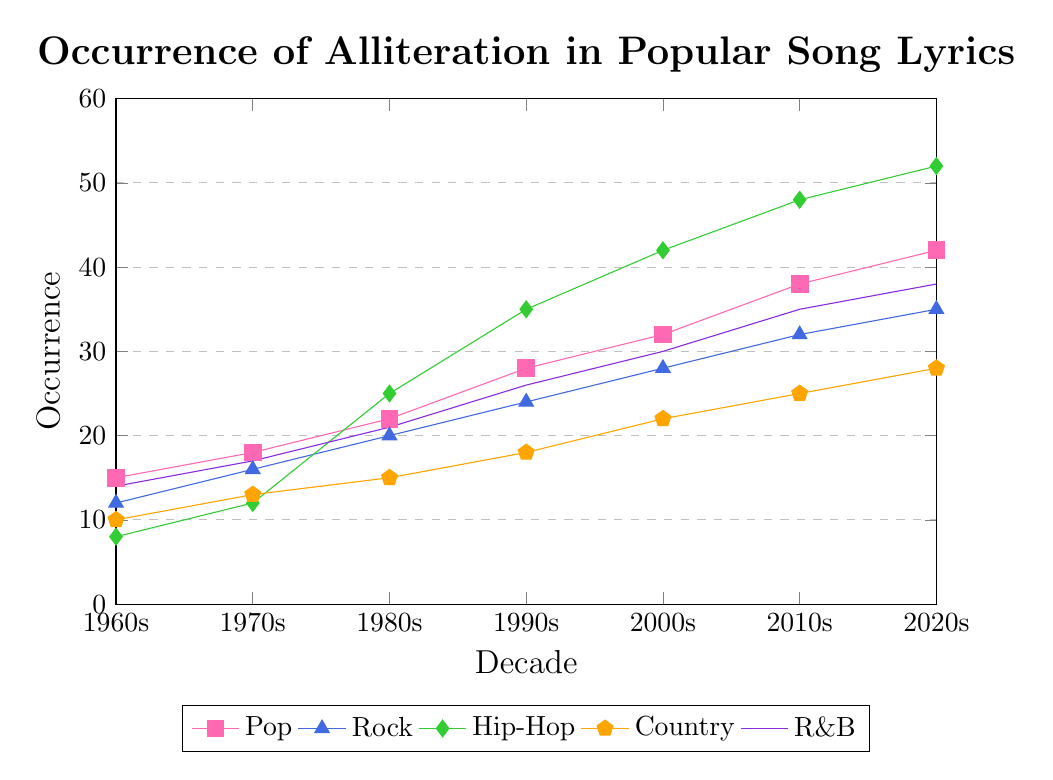What genre saw the most significant increase in alliteration occurrence from the 1960s to the 2020s? To determine this, calculate the difference in occurrences between the 2020s and the 1960s for each genre: Pop (42-15=27), Rock (35-12=23), Hip-Hop (52-8=44), Country (28-10=18), R&B (38-14=24). The largest increase was in Hip-Hop (44).
Answer: Hip-Hop Which genre had the highest occurrence of alliteration in the 1980s? Directly refer to the data points for the 1980s: Pop (22), Rock (20), Hip-Hop (25), Country (15), R&B (21). The highest value is for Hip-Hop (25).
Answer: Hip-Hop How does the occurrence of alliteration in Pop lyrics in the 2000s compare to that in Rock lyrics in the same decade? Look at the values for the 2000s: Pop (32), Rock (28). 32 is greater than 28.
Answer: Pop is higher What are the total occurrences of alliteration across all genres in the 2020s? Sum the values for the 2020s: Pop (42), Rock (35), Hip-Hop (52), Country (28), R&B (38). 42+35+52+28+38 = 195.
Answer: 195 How did the alliteration occurrence in Country lyrics change from the 1990s to the 2010s? Subtract the 1990s value from the 2010s value for Country: 25-18 = 7.
Answer: Increased by 7 In what decade did Hip-Hop lyrics first surpass 40 occurrences of alliteration? Examine the values for Hip-Hop: 8 (1960s), 12 (1970s), 25 (1980s), 35 (1990s), 42 (2000s), 48 (2010s), 52 (2020s). Hip-Hop first surpassed 40 in the 2000s.
Answer: 2000s Which genre consistently shows the second-highest occurrence of alliteration from the 2000s to the 2020s? Compare the values: 2000s: Pop (32), Rock (28), Hip-Hop (42), Country (22), R&B (30). 2010s: Pop (38), Rock (32), Hip-Hop (48), Country (25), R&B (35). 2020s: Pop (42), Rock (35), Hip-Hop (52), Country (28), R&B (38). R&B consistently has the second-highest occurrence in these decades.
Answer: R&B What was the average occurrence of alliteration in Pop lyrics over all the decades given? Sum the values for Pop (15, 18, 22, 28, 32, 38, 42) = 195, and then divide by the number of decades (7): 195/7 = 27.86.
Answer: 27.86 By how much did the occurrence of alliteration in Rock lyrics increase from the 1970s to the 2000s? Subtract the 1970s value from the 2000s value for Rock: 28-16 = 12.
Answer: Increased by 12 